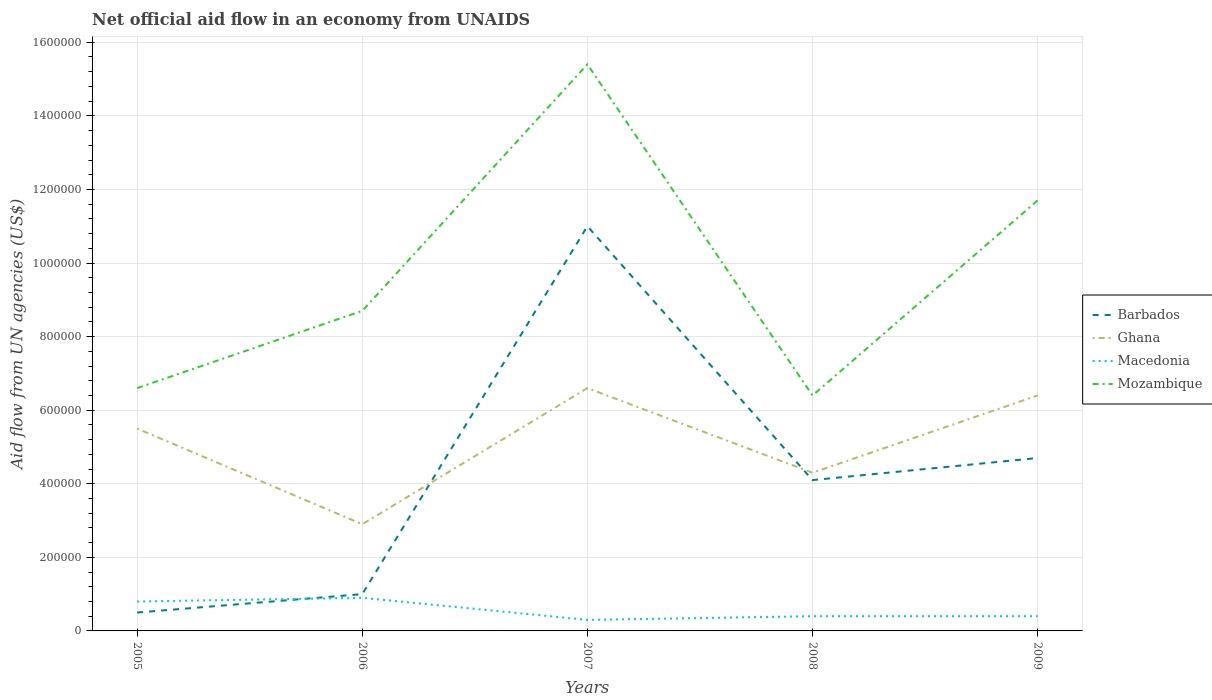How many different coloured lines are there?
Make the answer very short. 4. Is the number of lines equal to the number of legend labels?
Offer a terse response. Yes. What is the total net official aid flow in Mozambique in the graph?
Your response must be concise. -2.10e+05. What is the difference between the highest and the second highest net official aid flow in Ghana?
Your response must be concise. 3.70e+05. Is the net official aid flow in Macedonia strictly greater than the net official aid flow in Barbados over the years?
Ensure brevity in your answer.  No. What is the difference between two consecutive major ticks on the Y-axis?
Provide a succinct answer. 2.00e+05. Does the graph contain any zero values?
Provide a short and direct response. No. Where does the legend appear in the graph?
Give a very brief answer. Center right. What is the title of the graph?
Offer a very short reply. Net official aid flow in an economy from UNAIDS. Does "United Arab Emirates" appear as one of the legend labels in the graph?
Your answer should be compact. No. What is the label or title of the X-axis?
Your response must be concise. Years. What is the label or title of the Y-axis?
Make the answer very short. Aid flow from UN agencies (US$). What is the Aid flow from UN agencies (US$) of Macedonia in 2005?
Ensure brevity in your answer.  8.00e+04. What is the Aid flow from UN agencies (US$) in Macedonia in 2006?
Give a very brief answer. 9.00e+04. What is the Aid flow from UN agencies (US$) of Mozambique in 2006?
Ensure brevity in your answer.  8.70e+05. What is the Aid flow from UN agencies (US$) in Barbados in 2007?
Offer a very short reply. 1.10e+06. What is the Aid flow from UN agencies (US$) in Ghana in 2007?
Provide a succinct answer. 6.60e+05. What is the Aid flow from UN agencies (US$) in Mozambique in 2007?
Offer a very short reply. 1.54e+06. What is the Aid flow from UN agencies (US$) of Barbados in 2008?
Offer a very short reply. 4.10e+05. What is the Aid flow from UN agencies (US$) in Ghana in 2008?
Provide a succinct answer. 4.30e+05. What is the Aid flow from UN agencies (US$) of Macedonia in 2008?
Your answer should be compact. 4.00e+04. What is the Aid flow from UN agencies (US$) in Mozambique in 2008?
Your answer should be very brief. 6.40e+05. What is the Aid flow from UN agencies (US$) in Barbados in 2009?
Your answer should be very brief. 4.70e+05. What is the Aid flow from UN agencies (US$) in Ghana in 2009?
Your answer should be very brief. 6.40e+05. What is the Aid flow from UN agencies (US$) in Macedonia in 2009?
Keep it short and to the point. 4.00e+04. What is the Aid flow from UN agencies (US$) of Mozambique in 2009?
Offer a very short reply. 1.17e+06. Across all years, what is the maximum Aid flow from UN agencies (US$) of Barbados?
Make the answer very short. 1.10e+06. Across all years, what is the maximum Aid flow from UN agencies (US$) in Ghana?
Your answer should be compact. 6.60e+05. Across all years, what is the maximum Aid flow from UN agencies (US$) in Mozambique?
Offer a terse response. 1.54e+06. Across all years, what is the minimum Aid flow from UN agencies (US$) in Macedonia?
Your answer should be very brief. 3.00e+04. Across all years, what is the minimum Aid flow from UN agencies (US$) of Mozambique?
Make the answer very short. 6.40e+05. What is the total Aid flow from UN agencies (US$) in Barbados in the graph?
Your answer should be compact. 2.13e+06. What is the total Aid flow from UN agencies (US$) of Ghana in the graph?
Give a very brief answer. 2.57e+06. What is the total Aid flow from UN agencies (US$) of Mozambique in the graph?
Provide a succinct answer. 4.88e+06. What is the difference between the Aid flow from UN agencies (US$) of Barbados in 2005 and that in 2006?
Give a very brief answer. -5.00e+04. What is the difference between the Aid flow from UN agencies (US$) in Ghana in 2005 and that in 2006?
Make the answer very short. 2.60e+05. What is the difference between the Aid flow from UN agencies (US$) of Barbados in 2005 and that in 2007?
Give a very brief answer. -1.05e+06. What is the difference between the Aid flow from UN agencies (US$) of Ghana in 2005 and that in 2007?
Provide a succinct answer. -1.10e+05. What is the difference between the Aid flow from UN agencies (US$) of Macedonia in 2005 and that in 2007?
Make the answer very short. 5.00e+04. What is the difference between the Aid flow from UN agencies (US$) in Mozambique in 2005 and that in 2007?
Your answer should be compact. -8.80e+05. What is the difference between the Aid flow from UN agencies (US$) of Barbados in 2005 and that in 2008?
Your answer should be compact. -3.60e+05. What is the difference between the Aid flow from UN agencies (US$) in Ghana in 2005 and that in 2008?
Offer a very short reply. 1.20e+05. What is the difference between the Aid flow from UN agencies (US$) of Barbados in 2005 and that in 2009?
Offer a very short reply. -4.20e+05. What is the difference between the Aid flow from UN agencies (US$) of Ghana in 2005 and that in 2009?
Provide a short and direct response. -9.00e+04. What is the difference between the Aid flow from UN agencies (US$) of Macedonia in 2005 and that in 2009?
Give a very brief answer. 4.00e+04. What is the difference between the Aid flow from UN agencies (US$) of Mozambique in 2005 and that in 2009?
Make the answer very short. -5.10e+05. What is the difference between the Aid flow from UN agencies (US$) in Ghana in 2006 and that in 2007?
Your answer should be very brief. -3.70e+05. What is the difference between the Aid flow from UN agencies (US$) of Mozambique in 2006 and that in 2007?
Give a very brief answer. -6.70e+05. What is the difference between the Aid flow from UN agencies (US$) in Barbados in 2006 and that in 2008?
Offer a very short reply. -3.10e+05. What is the difference between the Aid flow from UN agencies (US$) of Ghana in 2006 and that in 2008?
Your response must be concise. -1.40e+05. What is the difference between the Aid flow from UN agencies (US$) of Macedonia in 2006 and that in 2008?
Ensure brevity in your answer.  5.00e+04. What is the difference between the Aid flow from UN agencies (US$) of Barbados in 2006 and that in 2009?
Keep it short and to the point. -3.70e+05. What is the difference between the Aid flow from UN agencies (US$) of Ghana in 2006 and that in 2009?
Your response must be concise. -3.50e+05. What is the difference between the Aid flow from UN agencies (US$) in Macedonia in 2006 and that in 2009?
Your answer should be very brief. 5.00e+04. What is the difference between the Aid flow from UN agencies (US$) of Mozambique in 2006 and that in 2009?
Provide a short and direct response. -3.00e+05. What is the difference between the Aid flow from UN agencies (US$) in Barbados in 2007 and that in 2008?
Your response must be concise. 6.90e+05. What is the difference between the Aid flow from UN agencies (US$) in Macedonia in 2007 and that in 2008?
Offer a very short reply. -10000. What is the difference between the Aid flow from UN agencies (US$) of Mozambique in 2007 and that in 2008?
Make the answer very short. 9.00e+05. What is the difference between the Aid flow from UN agencies (US$) of Barbados in 2007 and that in 2009?
Give a very brief answer. 6.30e+05. What is the difference between the Aid flow from UN agencies (US$) of Macedonia in 2008 and that in 2009?
Give a very brief answer. 0. What is the difference between the Aid flow from UN agencies (US$) in Mozambique in 2008 and that in 2009?
Your response must be concise. -5.30e+05. What is the difference between the Aid flow from UN agencies (US$) in Barbados in 2005 and the Aid flow from UN agencies (US$) in Ghana in 2006?
Offer a very short reply. -2.40e+05. What is the difference between the Aid flow from UN agencies (US$) of Barbados in 2005 and the Aid flow from UN agencies (US$) of Mozambique in 2006?
Your answer should be compact. -8.20e+05. What is the difference between the Aid flow from UN agencies (US$) of Ghana in 2005 and the Aid flow from UN agencies (US$) of Macedonia in 2006?
Keep it short and to the point. 4.60e+05. What is the difference between the Aid flow from UN agencies (US$) in Ghana in 2005 and the Aid flow from UN agencies (US$) in Mozambique in 2006?
Make the answer very short. -3.20e+05. What is the difference between the Aid flow from UN agencies (US$) in Macedonia in 2005 and the Aid flow from UN agencies (US$) in Mozambique in 2006?
Give a very brief answer. -7.90e+05. What is the difference between the Aid flow from UN agencies (US$) of Barbados in 2005 and the Aid flow from UN agencies (US$) of Ghana in 2007?
Your answer should be very brief. -6.10e+05. What is the difference between the Aid flow from UN agencies (US$) of Barbados in 2005 and the Aid flow from UN agencies (US$) of Macedonia in 2007?
Ensure brevity in your answer.  2.00e+04. What is the difference between the Aid flow from UN agencies (US$) in Barbados in 2005 and the Aid flow from UN agencies (US$) in Mozambique in 2007?
Your answer should be compact. -1.49e+06. What is the difference between the Aid flow from UN agencies (US$) in Ghana in 2005 and the Aid flow from UN agencies (US$) in Macedonia in 2007?
Make the answer very short. 5.20e+05. What is the difference between the Aid flow from UN agencies (US$) of Ghana in 2005 and the Aid flow from UN agencies (US$) of Mozambique in 2007?
Keep it short and to the point. -9.90e+05. What is the difference between the Aid flow from UN agencies (US$) of Macedonia in 2005 and the Aid flow from UN agencies (US$) of Mozambique in 2007?
Give a very brief answer. -1.46e+06. What is the difference between the Aid flow from UN agencies (US$) of Barbados in 2005 and the Aid flow from UN agencies (US$) of Ghana in 2008?
Ensure brevity in your answer.  -3.80e+05. What is the difference between the Aid flow from UN agencies (US$) of Barbados in 2005 and the Aid flow from UN agencies (US$) of Macedonia in 2008?
Offer a terse response. 10000. What is the difference between the Aid flow from UN agencies (US$) of Barbados in 2005 and the Aid flow from UN agencies (US$) of Mozambique in 2008?
Your answer should be very brief. -5.90e+05. What is the difference between the Aid flow from UN agencies (US$) in Ghana in 2005 and the Aid flow from UN agencies (US$) in Macedonia in 2008?
Keep it short and to the point. 5.10e+05. What is the difference between the Aid flow from UN agencies (US$) of Macedonia in 2005 and the Aid flow from UN agencies (US$) of Mozambique in 2008?
Offer a terse response. -5.60e+05. What is the difference between the Aid flow from UN agencies (US$) in Barbados in 2005 and the Aid flow from UN agencies (US$) in Ghana in 2009?
Provide a short and direct response. -5.90e+05. What is the difference between the Aid flow from UN agencies (US$) in Barbados in 2005 and the Aid flow from UN agencies (US$) in Mozambique in 2009?
Keep it short and to the point. -1.12e+06. What is the difference between the Aid flow from UN agencies (US$) of Ghana in 2005 and the Aid flow from UN agencies (US$) of Macedonia in 2009?
Give a very brief answer. 5.10e+05. What is the difference between the Aid flow from UN agencies (US$) in Ghana in 2005 and the Aid flow from UN agencies (US$) in Mozambique in 2009?
Keep it short and to the point. -6.20e+05. What is the difference between the Aid flow from UN agencies (US$) of Macedonia in 2005 and the Aid flow from UN agencies (US$) of Mozambique in 2009?
Your answer should be compact. -1.09e+06. What is the difference between the Aid flow from UN agencies (US$) in Barbados in 2006 and the Aid flow from UN agencies (US$) in Ghana in 2007?
Offer a terse response. -5.60e+05. What is the difference between the Aid flow from UN agencies (US$) of Barbados in 2006 and the Aid flow from UN agencies (US$) of Macedonia in 2007?
Offer a terse response. 7.00e+04. What is the difference between the Aid flow from UN agencies (US$) in Barbados in 2006 and the Aid flow from UN agencies (US$) in Mozambique in 2007?
Offer a terse response. -1.44e+06. What is the difference between the Aid flow from UN agencies (US$) in Ghana in 2006 and the Aid flow from UN agencies (US$) in Mozambique in 2007?
Offer a very short reply. -1.25e+06. What is the difference between the Aid flow from UN agencies (US$) of Macedonia in 2006 and the Aid flow from UN agencies (US$) of Mozambique in 2007?
Provide a succinct answer. -1.45e+06. What is the difference between the Aid flow from UN agencies (US$) in Barbados in 2006 and the Aid flow from UN agencies (US$) in Ghana in 2008?
Your answer should be very brief. -3.30e+05. What is the difference between the Aid flow from UN agencies (US$) of Barbados in 2006 and the Aid flow from UN agencies (US$) of Macedonia in 2008?
Keep it short and to the point. 6.00e+04. What is the difference between the Aid flow from UN agencies (US$) in Barbados in 2006 and the Aid flow from UN agencies (US$) in Mozambique in 2008?
Your answer should be compact. -5.40e+05. What is the difference between the Aid flow from UN agencies (US$) in Ghana in 2006 and the Aid flow from UN agencies (US$) in Mozambique in 2008?
Your answer should be compact. -3.50e+05. What is the difference between the Aid flow from UN agencies (US$) in Macedonia in 2006 and the Aid flow from UN agencies (US$) in Mozambique in 2008?
Keep it short and to the point. -5.50e+05. What is the difference between the Aid flow from UN agencies (US$) in Barbados in 2006 and the Aid flow from UN agencies (US$) in Ghana in 2009?
Give a very brief answer. -5.40e+05. What is the difference between the Aid flow from UN agencies (US$) in Barbados in 2006 and the Aid flow from UN agencies (US$) in Mozambique in 2009?
Keep it short and to the point. -1.07e+06. What is the difference between the Aid flow from UN agencies (US$) in Ghana in 2006 and the Aid flow from UN agencies (US$) in Macedonia in 2009?
Your answer should be very brief. 2.50e+05. What is the difference between the Aid flow from UN agencies (US$) in Ghana in 2006 and the Aid flow from UN agencies (US$) in Mozambique in 2009?
Make the answer very short. -8.80e+05. What is the difference between the Aid flow from UN agencies (US$) in Macedonia in 2006 and the Aid flow from UN agencies (US$) in Mozambique in 2009?
Keep it short and to the point. -1.08e+06. What is the difference between the Aid flow from UN agencies (US$) in Barbados in 2007 and the Aid flow from UN agencies (US$) in Ghana in 2008?
Provide a short and direct response. 6.70e+05. What is the difference between the Aid flow from UN agencies (US$) of Barbados in 2007 and the Aid flow from UN agencies (US$) of Macedonia in 2008?
Offer a terse response. 1.06e+06. What is the difference between the Aid flow from UN agencies (US$) in Ghana in 2007 and the Aid flow from UN agencies (US$) in Macedonia in 2008?
Make the answer very short. 6.20e+05. What is the difference between the Aid flow from UN agencies (US$) of Macedonia in 2007 and the Aid flow from UN agencies (US$) of Mozambique in 2008?
Offer a terse response. -6.10e+05. What is the difference between the Aid flow from UN agencies (US$) of Barbados in 2007 and the Aid flow from UN agencies (US$) of Ghana in 2009?
Ensure brevity in your answer.  4.60e+05. What is the difference between the Aid flow from UN agencies (US$) in Barbados in 2007 and the Aid flow from UN agencies (US$) in Macedonia in 2009?
Your answer should be compact. 1.06e+06. What is the difference between the Aid flow from UN agencies (US$) of Ghana in 2007 and the Aid flow from UN agencies (US$) of Macedonia in 2009?
Make the answer very short. 6.20e+05. What is the difference between the Aid flow from UN agencies (US$) in Ghana in 2007 and the Aid flow from UN agencies (US$) in Mozambique in 2009?
Provide a succinct answer. -5.10e+05. What is the difference between the Aid flow from UN agencies (US$) in Macedonia in 2007 and the Aid flow from UN agencies (US$) in Mozambique in 2009?
Your response must be concise. -1.14e+06. What is the difference between the Aid flow from UN agencies (US$) in Barbados in 2008 and the Aid flow from UN agencies (US$) in Ghana in 2009?
Give a very brief answer. -2.30e+05. What is the difference between the Aid flow from UN agencies (US$) of Barbados in 2008 and the Aid flow from UN agencies (US$) of Mozambique in 2009?
Keep it short and to the point. -7.60e+05. What is the difference between the Aid flow from UN agencies (US$) in Ghana in 2008 and the Aid flow from UN agencies (US$) in Macedonia in 2009?
Ensure brevity in your answer.  3.90e+05. What is the difference between the Aid flow from UN agencies (US$) of Ghana in 2008 and the Aid flow from UN agencies (US$) of Mozambique in 2009?
Provide a succinct answer. -7.40e+05. What is the difference between the Aid flow from UN agencies (US$) of Macedonia in 2008 and the Aid flow from UN agencies (US$) of Mozambique in 2009?
Provide a short and direct response. -1.13e+06. What is the average Aid flow from UN agencies (US$) of Barbados per year?
Ensure brevity in your answer.  4.26e+05. What is the average Aid flow from UN agencies (US$) in Ghana per year?
Your response must be concise. 5.14e+05. What is the average Aid flow from UN agencies (US$) of Macedonia per year?
Offer a very short reply. 5.60e+04. What is the average Aid flow from UN agencies (US$) of Mozambique per year?
Offer a very short reply. 9.76e+05. In the year 2005, what is the difference between the Aid flow from UN agencies (US$) in Barbados and Aid flow from UN agencies (US$) in Ghana?
Offer a terse response. -5.00e+05. In the year 2005, what is the difference between the Aid flow from UN agencies (US$) of Barbados and Aid flow from UN agencies (US$) of Mozambique?
Offer a terse response. -6.10e+05. In the year 2005, what is the difference between the Aid flow from UN agencies (US$) of Ghana and Aid flow from UN agencies (US$) of Macedonia?
Keep it short and to the point. 4.70e+05. In the year 2005, what is the difference between the Aid flow from UN agencies (US$) of Ghana and Aid flow from UN agencies (US$) of Mozambique?
Your answer should be very brief. -1.10e+05. In the year 2005, what is the difference between the Aid flow from UN agencies (US$) in Macedonia and Aid flow from UN agencies (US$) in Mozambique?
Keep it short and to the point. -5.80e+05. In the year 2006, what is the difference between the Aid flow from UN agencies (US$) of Barbados and Aid flow from UN agencies (US$) of Ghana?
Make the answer very short. -1.90e+05. In the year 2006, what is the difference between the Aid flow from UN agencies (US$) in Barbados and Aid flow from UN agencies (US$) in Macedonia?
Your answer should be compact. 10000. In the year 2006, what is the difference between the Aid flow from UN agencies (US$) of Barbados and Aid flow from UN agencies (US$) of Mozambique?
Provide a succinct answer. -7.70e+05. In the year 2006, what is the difference between the Aid flow from UN agencies (US$) in Ghana and Aid flow from UN agencies (US$) in Mozambique?
Provide a succinct answer. -5.80e+05. In the year 2006, what is the difference between the Aid flow from UN agencies (US$) in Macedonia and Aid flow from UN agencies (US$) in Mozambique?
Offer a terse response. -7.80e+05. In the year 2007, what is the difference between the Aid flow from UN agencies (US$) in Barbados and Aid flow from UN agencies (US$) in Macedonia?
Offer a terse response. 1.07e+06. In the year 2007, what is the difference between the Aid flow from UN agencies (US$) of Barbados and Aid flow from UN agencies (US$) of Mozambique?
Keep it short and to the point. -4.40e+05. In the year 2007, what is the difference between the Aid flow from UN agencies (US$) in Ghana and Aid flow from UN agencies (US$) in Macedonia?
Give a very brief answer. 6.30e+05. In the year 2007, what is the difference between the Aid flow from UN agencies (US$) of Ghana and Aid flow from UN agencies (US$) of Mozambique?
Your answer should be compact. -8.80e+05. In the year 2007, what is the difference between the Aid flow from UN agencies (US$) in Macedonia and Aid flow from UN agencies (US$) in Mozambique?
Ensure brevity in your answer.  -1.51e+06. In the year 2008, what is the difference between the Aid flow from UN agencies (US$) of Barbados and Aid flow from UN agencies (US$) of Mozambique?
Make the answer very short. -2.30e+05. In the year 2008, what is the difference between the Aid flow from UN agencies (US$) in Macedonia and Aid flow from UN agencies (US$) in Mozambique?
Offer a terse response. -6.00e+05. In the year 2009, what is the difference between the Aid flow from UN agencies (US$) of Barbados and Aid flow from UN agencies (US$) of Mozambique?
Make the answer very short. -7.00e+05. In the year 2009, what is the difference between the Aid flow from UN agencies (US$) in Ghana and Aid flow from UN agencies (US$) in Mozambique?
Offer a very short reply. -5.30e+05. In the year 2009, what is the difference between the Aid flow from UN agencies (US$) of Macedonia and Aid flow from UN agencies (US$) of Mozambique?
Provide a short and direct response. -1.13e+06. What is the ratio of the Aid flow from UN agencies (US$) in Ghana in 2005 to that in 2006?
Keep it short and to the point. 1.9. What is the ratio of the Aid flow from UN agencies (US$) in Macedonia in 2005 to that in 2006?
Your response must be concise. 0.89. What is the ratio of the Aid flow from UN agencies (US$) in Mozambique in 2005 to that in 2006?
Offer a terse response. 0.76. What is the ratio of the Aid flow from UN agencies (US$) in Barbados in 2005 to that in 2007?
Your answer should be very brief. 0.05. What is the ratio of the Aid flow from UN agencies (US$) of Ghana in 2005 to that in 2007?
Your response must be concise. 0.83. What is the ratio of the Aid flow from UN agencies (US$) of Macedonia in 2005 to that in 2007?
Offer a very short reply. 2.67. What is the ratio of the Aid flow from UN agencies (US$) in Mozambique in 2005 to that in 2007?
Your answer should be compact. 0.43. What is the ratio of the Aid flow from UN agencies (US$) in Barbados in 2005 to that in 2008?
Your answer should be very brief. 0.12. What is the ratio of the Aid flow from UN agencies (US$) of Ghana in 2005 to that in 2008?
Make the answer very short. 1.28. What is the ratio of the Aid flow from UN agencies (US$) of Mozambique in 2005 to that in 2008?
Give a very brief answer. 1.03. What is the ratio of the Aid flow from UN agencies (US$) in Barbados in 2005 to that in 2009?
Offer a very short reply. 0.11. What is the ratio of the Aid flow from UN agencies (US$) in Ghana in 2005 to that in 2009?
Ensure brevity in your answer.  0.86. What is the ratio of the Aid flow from UN agencies (US$) of Macedonia in 2005 to that in 2009?
Provide a succinct answer. 2. What is the ratio of the Aid flow from UN agencies (US$) in Mozambique in 2005 to that in 2009?
Offer a terse response. 0.56. What is the ratio of the Aid flow from UN agencies (US$) in Barbados in 2006 to that in 2007?
Your answer should be very brief. 0.09. What is the ratio of the Aid flow from UN agencies (US$) in Ghana in 2006 to that in 2007?
Offer a terse response. 0.44. What is the ratio of the Aid flow from UN agencies (US$) in Mozambique in 2006 to that in 2007?
Offer a very short reply. 0.56. What is the ratio of the Aid flow from UN agencies (US$) in Barbados in 2006 to that in 2008?
Provide a short and direct response. 0.24. What is the ratio of the Aid flow from UN agencies (US$) in Ghana in 2006 to that in 2008?
Keep it short and to the point. 0.67. What is the ratio of the Aid flow from UN agencies (US$) of Macedonia in 2006 to that in 2008?
Give a very brief answer. 2.25. What is the ratio of the Aid flow from UN agencies (US$) in Mozambique in 2006 to that in 2008?
Keep it short and to the point. 1.36. What is the ratio of the Aid flow from UN agencies (US$) of Barbados in 2006 to that in 2009?
Give a very brief answer. 0.21. What is the ratio of the Aid flow from UN agencies (US$) of Ghana in 2006 to that in 2009?
Ensure brevity in your answer.  0.45. What is the ratio of the Aid flow from UN agencies (US$) in Macedonia in 2006 to that in 2009?
Provide a succinct answer. 2.25. What is the ratio of the Aid flow from UN agencies (US$) of Mozambique in 2006 to that in 2009?
Provide a succinct answer. 0.74. What is the ratio of the Aid flow from UN agencies (US$) in Barbados in 2007 to that in 2008?
Make the answer very short. 2.68. What is the ratio of the Aid flow from UN agencies (US$) in Ghana in 2007 to that in 2008?
Keep it short and to the point. 1.53. What is the ratio of the Aid flow from UN agencies (US$) in Macedonia in 2007 to that in 2008?
Your response must be concise. 0.75. What is the ratio of the Aid flow from UN agencies (US$) in Mozambique in 2007 to that in 2008?
Make the answer very short. 2.41. What is the ratio of the Aid flow from UN agencies (US$) in Barbados in 2007 to that in 2009?
Offer a terse response. 2.34. What is the ratio of the Aid flow from UN agencies (US$) in Ghana in 2007 to that in 2009?
Your answer should be very brief. 1.03. What is the ratio of the Aid flow from UN agencies (US$) in Macedonia in 2007 to that in 2009?
Ensure brevity in your answer.  0.75. What is the ratio of the Aid flow from UN agencies (US$) in Mozambique in 2007 to that in 2009?
Your answer should be compact. 1.32. What is the ratio of the Aid flow from UN agencies (US$) of Barbados in 2008 to that in 2009?
Ensure brevity in your answer.  0.87. What is the ratio of the Aid flow from UN agencies (US$) of Ghana in 2008 to that in 2009?
Keep it short and to the point. 0.67. What is the ratio of the Aid flow from UN agencies (US$) in Macedonia in 2008 to that in 2009?
Ensure brevity in your answer.  1. What is the ratio of the Aid flow from UN agencies (US$) of Mozambique in 2008 to that in 2009?
Your response must be concise. 0.55. What is the difference between the highest and the second highest Aid flow from UN agencies (US$) in Barbados?
Your answer should be compact. 6.30e+05. What is the difference between the highest and the second highest Aid flow from UN agencies (US$) of Ghana?
Your answer should be very brief. 2.00e+04. What is the difference between the highest and the second highest Aid flow from UN agencies (US$) in Mozambique?
Give a very brief answer. 3.70e+05. What is the difference between the highest and the lowest Aid flow from UN agencies (US$) in Barbados?
Offer a terse response. 1.05e+06. What is the difference between the highest and the lowest Aid flow from UN agencies (US$) in Macedonia?
Give a very brief answer. 6.00e+04. What is the difference between the highest and the lowest Aid flow from UN agencies (US$) of Mozambique?
Your response must be concise. 9.00e+05. 